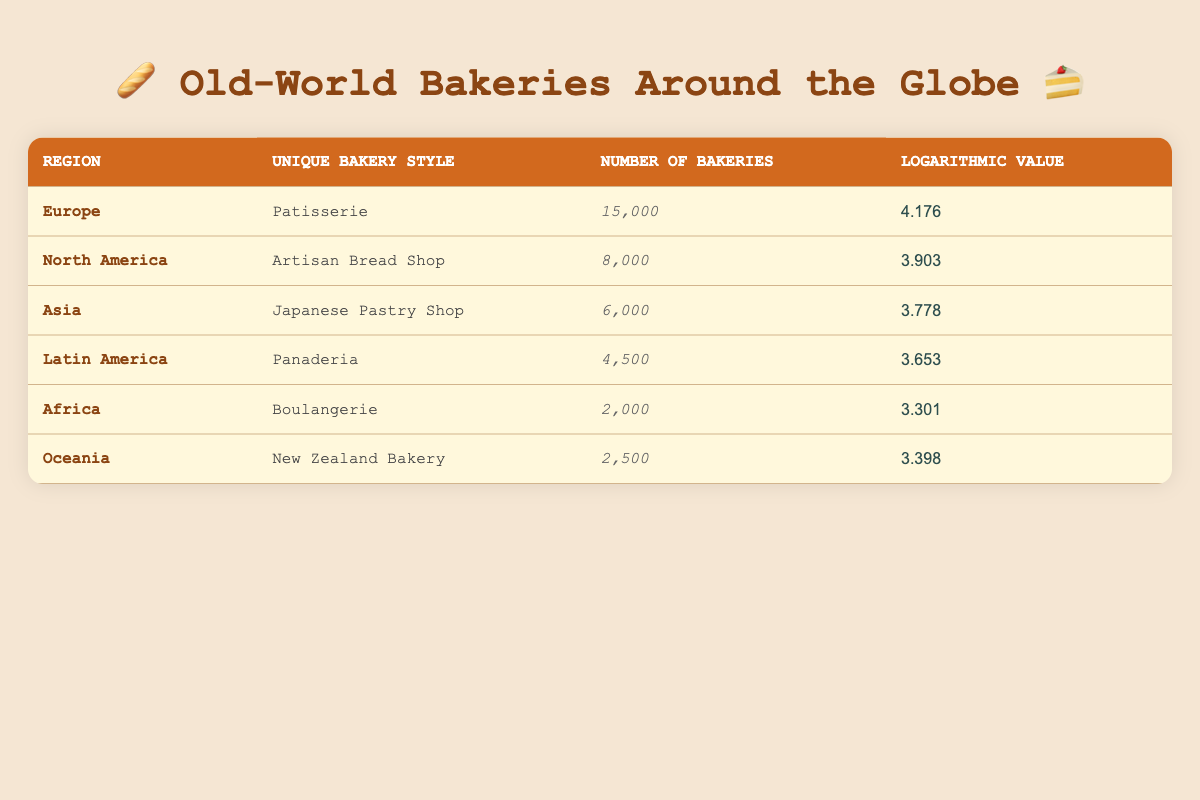What is the unique bakery style in Europe? From the table, we can see that the unique bakery style listed under the Europe region is Patisserie.
Answer: Patisserie How many Artisan Bread Shops are there in North America? The table indicates that there are 8,000 Artisan Bread Shops located in North America.
Answer: 8,000 Which region has the highest number of unique bakeries? By examining the number of bakeries, Europe has 15,000 bakeries, which is greater than any other region's count.
Answer: Europe What is the logarithmic value for the Japanese Pastry Shop? The table shows that the logarithmic value listed for the Japanese Pastry Shop in Asia is 3.778.
Answer: 3.778 Is there a Boulangerie in Latin America? Referring to the table, Boulangerie is listed under the Africa region, while Latin America has Panaderia, indicating that there is no Boulangerie in Latin America.
Answer: No What is the total number of bakeries represented in the table? The total number of bakeries can be found by summing the values across all regions: 15,000 + 8,000 + 6,000 + 4,500 + 2,000 + 2,500 = 38,000.
Answer: 38,000 What is the average number of bakeries across all regions? To find the average, we sum the number of bakeries (38,000) and divide by the number of unique regions (6): 38,000 / 6 = 6,333.33.
Answer: 6,333.33 Which region has a logarithmic value closest to 3.4? The regions of Africa and Oceania have logarithmic values of 3.301 and 3.398, respectively. Oceania is closest to 3.4 with its value of 3.398.
Answer: Oceania How many more bakeries does Europe have compared to Latin America? The difference in the number of bakeries is calculated as follows: 15,000 (Europe) - 4,500 (Latin America) = 10,500.
Answer: 10,500 